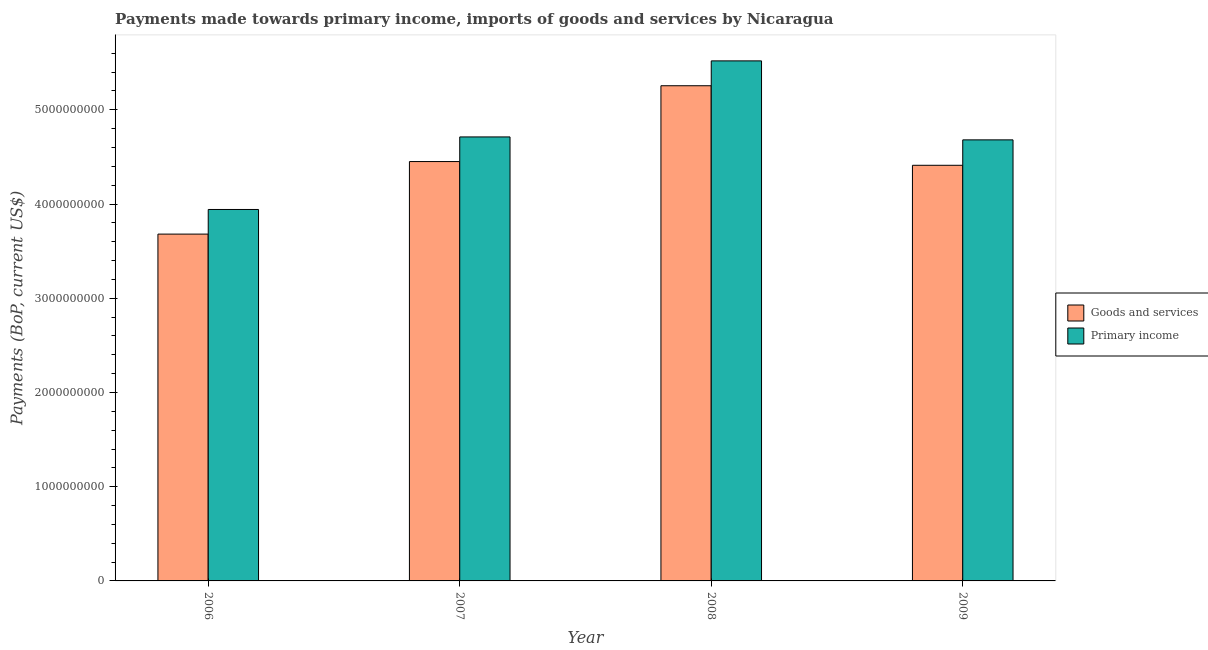Are the number of bars per tick equal to the number of legend labels?
Your answer should be very brief. Yes. Are the number of bars on each tick of the X-axis equal?
Provide a short and direct response. Yes. What is the label of the 3rd group of bars from the left?
Provide a succinct answer. 2008. What is the payments made towards goods and services in 2006?
Ensure brevity in your answer.  3.68e+09. Across all years, what is the maximum payments made towards primary income?
Provide a succinct answer. 5.52e+09. Across all years, what is the minimum payments made towards primary income?
Provide a succinct answer. 3.94e+09. What is the total payments made towards goods and services in the graph?
Your answer should be very brief. 1.78e+1. What is the difference between the payments made towards goods and services in 2007 and that in 2009?
Keep it short and to the point. 3.97e+07. What is the difference between the payments made towards goods and services in 2008 and the payments made towards primary income in 2007?
Ensure brevity in your answer.  8.05e+08. What is the average payments made towards goods and services per year?
Provide a short and direct response. 4.45e+09. In the year 2008, what is the difference between the payments made towards goods and services and payments made towards primary income?
Provide a succinct answer. 0. In how many years, is the payments made towards goods and services greater than 5200000000 US$?
Your answer should be very brief. 1. What is the ratio of the payments made towards primary income in 2006 to that in 2007?
Keep it short and to the point. 0.84. Is the payments made towards primary income in 2006 less than that in 2008?
Keep it short and to the point. Yes. Is the difference between the payments made towards goods and services in 2006 and 2009 greater than the difference between the payments made towards primary income in 2006 and 2009?
Offer a terse response. No. What is the difference between the highest and the second highest payments made towards primary income?
Provide a short and direct response. 8.07e+08. What is the difference between the highest and the lowest payments made towards goods and services?
Your response must be concise. 1.57e+09. In how many years, is the payments made towards goods and services greater than the average payments made towards goods and services taken over all years?
Your answer should be very brief. 2. Is the sum of the payments made towards goods and services in 2008 and 2009 greater than the maximum payments made towards primary income across all years?
Ensure brevity in your answer.  Yes. What does the 2nd bar from the left in 2009 represents?
Give a very brief answer. Primary income. What does the 1st bar from the right in 2009 represents?
Offer a very short reply. Primary income. How many bars are there?
Your answer should be compact. 8. Does the graph contain grids?
Keep it short and to the point. No. Where does the legend appear in the graph?
Make the answer very short. Center right. How are the legend labels stacked?
Make the answer very short. Vertical. What is the title of the graph?
Give a very brief answer. Payments made towards primary income, imports of goods and services by Nicaragua. Does "Male" appear as one of the legend labels in the graph?
Offer a terse response. No. What is the label or title of the Y-axis?
Offer a very short reply. Payments (BoP, current US$). What is the Payments (BoP, current US$) in Goods and services in 2006?
Provide a short and direct response. 3.68e+09. What is the Payments (BoP, current US$) of Primary income in 2006?
Keep it short and to the point. 3.94e+09. What is the Payments (BoP, current US$) of Goods and services in 2007?
Provide a succinct answer. 4.45e+09. What is the Payments (BoP, current US$) of Primary income in 2007?
Provide a succinct answer. 4.71e+09. What is the Payments (BoP, current US$) of Goods and services in 2008?
Ensure brevity in your answer.  5.26e+09. What is the Payments (BoP, current US$) in Primary income in 2008?
Ensure brevity in your answer.  5.52e+09. What is the Payments (BoP, current US$) of Goods and services in 2009?
Your response must be concise. 4.41e+09. What is the Payments (BoP, current US$) of Primary income in 2009?
Give a very brief answer. 4.68e+09. Across all years, what is the maximum Payments (BoP, current US$) in Goods and services?
Provide a succinct answer. 5.26e+09. Across all years, what is the maximum Payments (BoP, current US$) in Primary income?
Keep it short and to the point. 5.52e+09. Across all years, what is the minimum Payments (BoP, current US$) in Goods and services?
Your answer should be compact. 3.68e+09. Across all years, what is the minimum Payments (BoP, current US$) in Primary income?
Keep it short and to the point. 3.94e+09. What is the total Payments (BoP, current US$) of Goods and services in the graph?
Offer a very short reply. 1.78e+1. What is the total Payments (BoP, current US$) in Primary income in the graph?
Your answer should be compact. 1.89e+1. What is the difference between the Payments (BoP, current US$) in Goods and services in 2006 and that in 2007?
Your response must be concise. -7.70e+08. What is the difference between the Payments (BoP, current US$) in Primary income in 2006 and that in 2007?
Ensure brevity in your answer.  -7.70e+08. What is the difference between the Payments (BoP, current US$) of Goods and services in 2006 and that in 2008?
Your answer should be compact. -1.57e+09. What is the difference between the Payments (BoP, current US$) in Primary income in 2006 and that in 2008?
Provide a short and direct response. -1.58e+09. What is the difference between the Payments (BoP, current US$) in Goods and services in 2006 and that in 2009?
Your response must be concise. -7.30e+08. What is the difference between the Payments (BoP, current US$) in Primary income in 2006 and that in 2009?
Keep it short and to the point. -7.39e+08. What is the difference between the Payments (BoP, current US$) of Goods and services in 2007 and that in 2008?
Offer a very short reply. -8.05e+08. What is the difference between the Payments (BoP, current US$) of Primary income in 2007 and that in 2008?
Offer a terse response. -8.07e+08. What is the difference between the Payments (BoP, current US$) of Goods and services in 2007 and that in 2009?
Ensure brevity in your answer.  3.97e+07. What is the difference between the Payments (BoP, current US$) of Primary income in 2007 and that in 2009?
Provide a succinct answer. 3.12e+07. What is the difference between the Payments (BoP, current US$) of Goods and services in 2008 and that in 2009?
Provide a short and direct response. 8.44e+08. What is the difference between the Payments (BoP, current US$) of Primary income in 2008 and that in 2009?
Ensure brevity in your answer.  8.38e+08. What is the difference between the Payments (BoP, current US$) of Goods and services in 2006 and the Payments (BoP, current US$) of Primary income in 2007?
Ensure brevity in your answer.  -1.03e+09. What is the difference between the Payments (BoP, current US$) of Goods and services in 2006 and the Payments (BoP, current US$) of Primary income in 2008?
Ensure brevity in your answer.  -1.84e+09. What is the difference between the Payments (BoP, current US$) of Goods and services in 2006 and the Payments (BoP, current US$) of Primary income in 2009?
Offer a very short reply. -1.00e+09. What is the difference between the Payments (BoP, current US$) in Goods and services in 2007 and the Payments (BoP, current US$) in Primary income in 2008?
Your answer should be compact. -1.07e+09. What is the difference between the Payments (BoP, current US$) of Goods and services in 2007 and the Payments (BoP, current US$) of Primary income in 2009?
Ensure brevity in your answer.  -2.30e+08. What is the difference between the Payments (BoP, current US$) of Goods and services in 2008 and the Payments (BoP, current US$) of Primary income in 2009?
Provide a short and direct response. 5.74e+08. What is the average Payments (BoP, current US$) of Goods and services per year?
Give a very brief answer. 4.45e+09. What is the average Payments (BoP, current US$) in Primary income per year?
Provide a succinct answer. 4.71e+09. In the year 2006, what is the difference between the Payments (BoP, current US$) in Goods and services and Payments (BoP, current US$) in Primary income?
Ensure brevity in your answer.  -2.62e+08. In the year 2007, what is the difference between the Payments (BoP, current US$) in Goods and services and Payments (BoP, current US$) in Primary income?
Your answer should be compact. -2.61e+08. In the year 2008, what is the difference between the Payments (BoP, current US$) of Goods and services and Payments (BoP, current US$) of Primary income?
Ensure brevity in your answer.  -2.64e+08. In the year 2009, what is the difference between the Payments (BoP, current US$) of Goods and services and Payments (BoP, current US$) of Primary income?
Your response must be concise. -2.70e+08. What is the ratio of the Payments (BoP, current US$) in Goods and services in 2006 to that in 2007?
Make the answer very short. 0.83. What is the ratio of the Payments (BoP, current US$) in Primary income in 2006 to that in 2007?
Provide a succinct answer. 0.84. What is the ratio of the Payments (BoP, current US$) in Goods and services in 2006 to that in 2008?
Ensure brevity in your answer.  0.7. What is the ratio of the Payments (BoP, current US$) of Goods and services in 2006 to that in 2009?
Keep it short and to the point. 0.83. What is the ratio of the Payments (BoP, current US$) of Primary income in 2006 to that in 2009?
Your answer should be very brief. 0.84. What is the ratio of the Payments (BoP, current US$) of Goods and services in 2007 to that in 2008?
Offer a very short reply. 0.85. What is the ratio of the Payments (BoP, current US$) in Primary income in 2007 to that in 2008?
Provide a short and direct response. 0.85. What is the ratio of the Payments (BoP, current US$) in Goods and services in 2007 to that in 2009?
Offer a terse response. 1.01. What is the ratio of the Payments (BoP, current US$) of Primary income in 2007 to that in 2009?
Your answer should be compact. 1.01. What is the ratio of the Payments (BoP, current US$) in Goods and services in 2008 to that in 2009?
Ensure brevity in your answer.  1.19. What is the ratio of the Payments (BoP, current US$) in Primary income in 2008 to that in 2009?
Give a very brief answer. 1.18. What is the difference between the highest and the second highest Payments (BoP, current US$) in Goods and services?
Ensure brevity in your answer.  8.05e+08. What is the difference between the highest and the second highest Payments (BoP, current US$) in Primary income?
Provide a short and direct response. 8.07e+08. What is the difference between the highest and the lowest Payments (BoP, current US$) of Goods and services?
Provide a succinct answer. 1.57e+09. What is the difference between the highest and the lowest Payments (BoP, current US$) in Primary income?
Make the answer very short. 1.58e+09. 